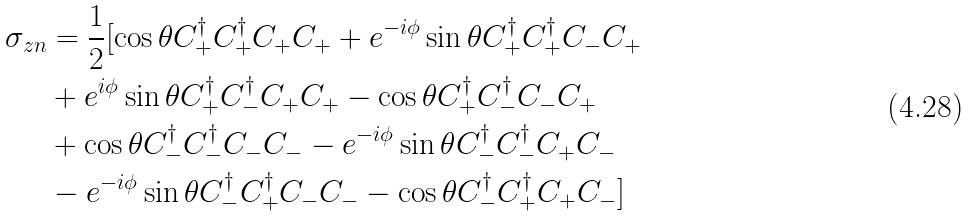<formula> <loc_0><loc_0><loc_500><loc_500>\sigma _ { z n } & = \frac { 1 } { 2 } [ \cos \theta C ^ { \dag } _ { + } C ^ { \dag } _ { + } C _ { + } C _ { + } + e ^ { - i \phi } \sin \theta C ^ { \dag } _ { + } C ^ { \dag } _ { + } C _ { - } C _ { + } \\ & + e ^ { i \phi } \sin \theta C ^ { \dag } _ { + } C ^ { \dag } _ { - } C _ { + } C _ { + } - \cos \theta C ^ { \dag } _ { + } C ^ { \dag } _ { - } C _ { - } C _ { + } \\ & + \cos \theta C ^ { \dag } _ { - } C ^ { \dag } _ { - } C _ { - } C _ { - } - e ^ { - i \phi } \sin \theta C ^ { \dag } _ { - } C ^ { \dag } _ { - } C _ { + } C _ { - } \\ & - e ^ { - i \phi } \sin \theta C ^ { \dag } _ { - } C ^ { \dag } _ { + } C _ { - } C _ { - } - \cos \theta C ^ { \dag } _ { - } C ^ { \dag } _ { + } C _ { + } C _ { - } ]</formula> 